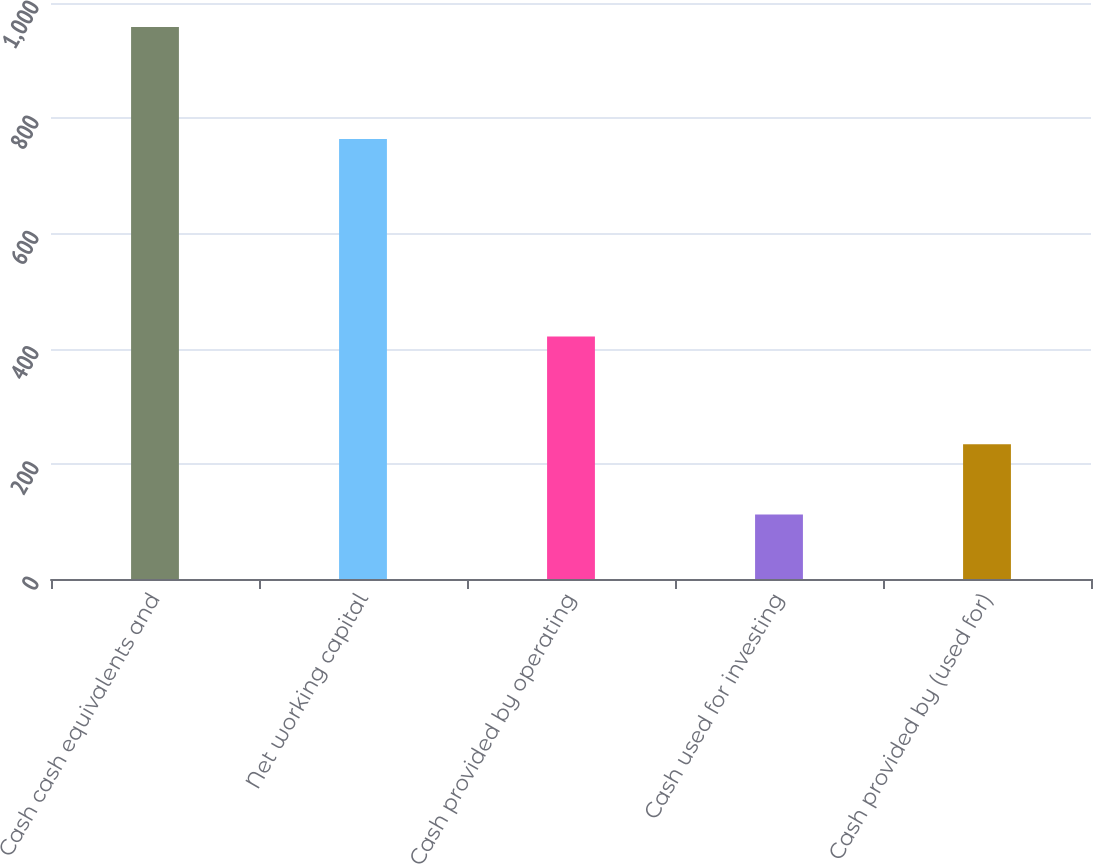Convert chart to OTSL. <chart><loc_0><loc_0><loc_500><loc_500><bar_chart><fcel>Cash cash equivalents and<fcel>Net working capital<fcel>Cash provided by operating<fcel>Cash used for investing<fcel>Cash provided by (used for)<nl><fcel>958.4<fcel>763.9<fcel>421.2<fcel>111.8<fcel>233.9<nl></chart> 